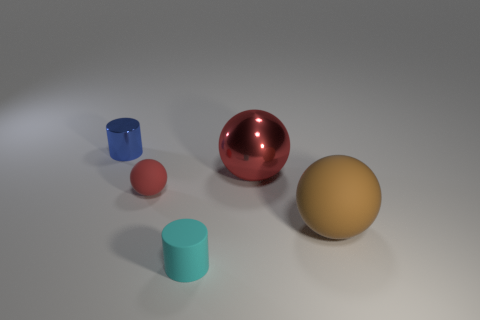The sphere that is made of the same material as the blue cylinder is what color?
Your response must be concise. Red. What number of blue cylinders have the same material as the large red thing?
Ensure brevity in your answer.  1. There is a big object that is on the right side of the metallic object in front of the shiny object that is to the left of the cyan rubber cylinder; what is its color?
Your answer should be compact. Brown. Does the blue shiny cylinder have the same size as the cyan matte cylinder?
Your response must be concise. Yes. Are there any other things that are the same shape as the brown object?
Your answer should be very brief. Yes. How many objects are large brown balls in front of the tiny red object or small cylinders?
Offer a terse response. 3. Is the shape of the red metal thing the same as the small cyan rubber thing?
Keep it short and to the point. No. What number of other things are there of the same size as the blue shiny object?
Your answer should be very brief. 2. The big metallic object is what color?
Your answer should be compact. Red. What number of small things are brown objects or purple metal things?
Your answer should be very brief. 0. 